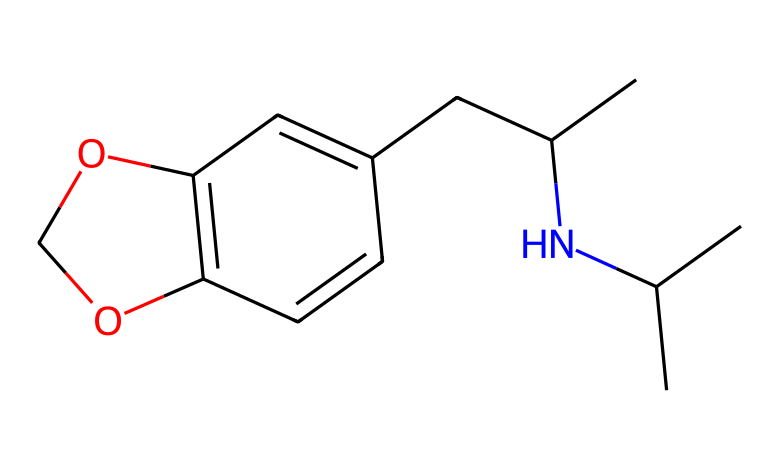What is the total number of carbon atoms in this chemical? By analyzing the provided SMILES representation, we count the total number of carbon (C) symbols, which indicate the presence of carbon atoms in the structure. In this case, there are 12 carbon atoms present in the chemical.
Answer: 12 How many oxygen atoms are present in the chemical? In the SMILES representation, we look for the oxygen (O) symbols to determine the count. There are two oxygen atoms in this structure, as indicated by the two occurrences of the letter "O".
Answer: 2 What type of molecule is indicated by the presence of nitrogen in this structure? The presence of nitrogen (N) in a chemical structure typically signifies that it is an amine or an alkaloid. Since this compound exhibits characteristics of psychoactive substances that may be used therapeutically, it can be categorized as a drug.
Answer: drug What functional group is evident in this chemical structure due to the ring formation? In the SMILES representation, the rings formed indicate the presence of a chemical structure known as a heterocyclic compound due to the presence of both carbon and nitrogen in a cyclic arrangement. This characteristic is essential for its psychoactive properties.
Answer: heterocyclic What is the likely biological activity of this chemical based on its structure? Given the structure’s similarity to known psychoactive substances like MDMA and psilocybin, which have been demonstrated to assist in therapy for trauma, it suggests that this compound may also exhibit similar therapeutic effects through its action on neurotransmitters in the brain.
Answer: psychoactive 